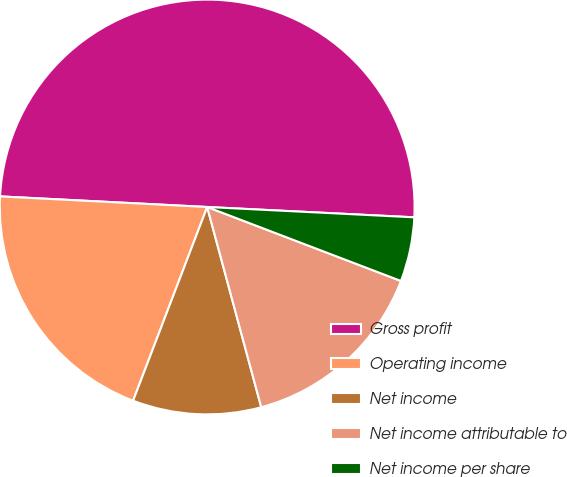Convert chart. <chart><loc_0><loc_0><loc_500><loc_500><pie_chart><fcel>Gross profit<fcel>Operating income<fcel>Net income<fcel>Net income attributable to<fcel>Net income per share<nl><fcel>49.98%<fcel>20.0%<fcel>10.01%<fcel>15.0%<fcel>5.01%<nl></chart> 